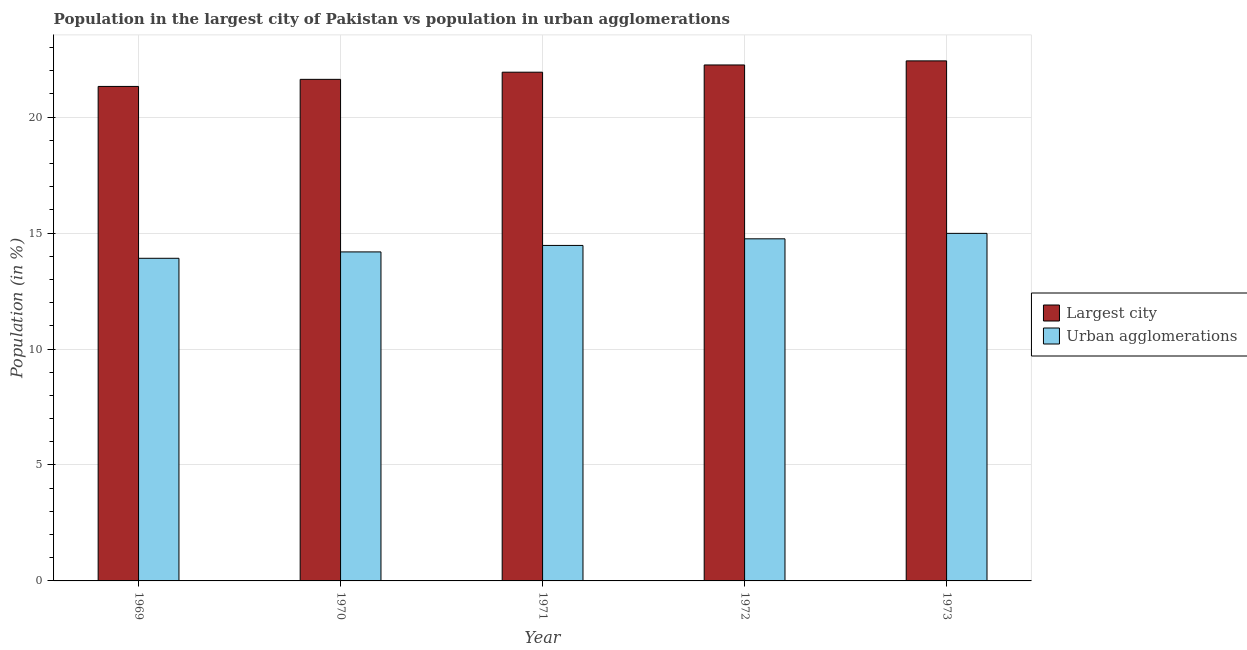How many bars are there on the 1st tick from the left?
Your response must be concise. 2. How many bars are there on the 2nd tick from the right?
Provide a short and direct response. 2. What is the label of the 5th group of bars from the left?
Offer a terse response. 1973. In how many cases, is the number of bars for a given year not equal to the number of legend labels?
Give a very brief answer. 0. What is the population in urban agglomerations in 1972?
Your answer should be compact. 14.75. Across all years, what is the maximum population in urban agglomerations?
Give a very brief answer. 14.99. Across all years, what is the minimum population in urban agglomerations?
Offer a terse response. 13.91. In which year was the population in urban agglomerations minimum?
Your answer should be compact. 1969. What is the total population in the largest city in the graph?
Ensure brevity in your answer.  109.58. What is the difference between the population in the largest city in 1969 and that in 1973?
Ensure brevity in your answer.  -1.1. What is the difference between the population in the largest city in 1969 and the population in urban agglomerations in 1970?
Keep it short and to the point. -0.31. What is the average population in the largest city per year?
Your response must be concise. 21.92. What is the ratio of the population in urban agglomerations in 1971 to that in 1972?
Your answer should be compact. 0.98. Is the difference between the population in the largest city in 1971 and 1972 greater than the difference between the population in urban agglomerations in 1971 and 1972?
Offer a terse response. No. What is the difference between the highest and the second highest population in the largest city?
Your response must be concise. 0.18. What is the difference between the highest and the lowest population in urban agglomerations?
Make the answer very short. 1.08. In how many years, is the population in urban agglomerations greater than the average population in urban agglomerations taken over all years?
Provide a short and direct response. 3. Is the sum of the population in urban agglomerations in 1972 and 1973 greater than the maximum population in the largest city across all years?
Provide a short and direct response. Yes. What does the 1st bar from the left in 1973 represents?
Provide a short and direct response. Largest city. What does the 2nd bar from the right in 1973 represents?
Your answer should be very brief. Largest city. What is the difference between two consecutive major ticks on the Y-axis?
Provide a short and direct response. 5. Are the values on the major ticks of Y-axis written in scientific E-notation?
Your answer should be very brief. No. How many legend labels are there?
Your response must be concise. 2. How are the legend labels stacked?
Your response must be concise. Vertical. What is the title of the graph?
Make the answer very short. Population in the largest city of Pakistan vs population in urban agglomerations. Does "Male entrants" appear as one of the legend labels in the graph?
Provide a succinct answer. No. What is the label or title of the X-axis?
Offer a terse response. Year. What is the Population (in %) of Largest city in 1969?
Offer a very short reply. 21.33. What is the Population (in %) in Urban agglomerations in 1969?
Provide a succinct answer. 13.91. What is the Population (in %) in Largest city in 1970?
Provide a succinct answer. 21.63. What is the Population (in %) of Urban agglomerations in 1970?
Give a very brief answer. 14.19. What is the Population (in %) in Largest city in 1971?
Keep it short and to the point. 21.94. What is the Population (in %) in Urban agglomerations in 1971?
Keep it short and to the point. 14.47. What is the Population (in %) in Largest city in 1972?
Keep it short and to the point. 22.25. What is the Population (in %) in Urban agglomerations in 1972?
Provide a short and direct response. 14.75. What is the Population (in %) in Largest city in 1973?
Your answer should be very brief. 22.43. What is the Population (in %) in Urban agglomerations in 1973?
Give a very brief answer. 14.99. Across all years, what is the maximum Population (in %) of Largest city?
Keep it short and to the point. 22.43. Across all years, what is the maximum Population (in %) in Urban agglomerations?
Your answer should be very brief. 14.99. Across all years, what is the minimum Population (in %) of Largest city?
Provide a short and direct response. 21.33. Across all years, what is the minimum Population (in %) of Urban agglomerations?
Give a very brief answer. 13.91. What is the total Population (in %) of Largest city in the graph?
Your response must be concise. 109.58. What is the total Population (in %) in Urban agglomerations in the graph?
Provide a short and direct response. 72.32. What is the difference between the Population (in %) in Largest city in 1969 and that in 1970?
Your answer should be very brief. -0.31. What is the difference between the Population (in %) of Urban agglomerations in 1969 and that in 1970?
Provide a short and direct response. -0.27. What is the difference between the Population (in %) of Largest city in 1969 and that in 1971?
Your answer should be very brief. -0.61. What is the difference between the Population (in %) in Urban agglomerations in 1969 and that in 1971?
Keep it short and to the point. -0.55. What is the difference between the Population (in %) in Largest city in 1969 and that in 1972?
Provide a succinct answer. -0.93. What is the difference between the Population (in %) in Urban agglomerations in 1969 and that in 1972?
Provide a succinct answer. -0.84. What is the difference between the Population (in %) of Largest city in 1969 and that in 1973?
Offer a terse response. -1.1. What is the difference between the Population (in %) of Urban agglomerations in 1969 and that in 1973?
Offer a terse response. -1.07. What is the difference between the Population (in %) of Largest city in 1970 and that in 1971?
Provide a succinct answer. -0.31. What is the difference between the Population (in %) in Urban agglomerations in 1970 and that in 1971?
Ensure brevity in your answer.  -0.28. What is the difference between the Population (in %) in Largest city in 1970 and that in 1972?
Offer a very short reply. -0.62. What is the difference between the Population (in %) in Urban agglomerations in 1970 and that in 1972?
Your response must be concise. -0.57. What is the difference between the Population (in %) in Largest city in 1970 and that in 1973?
Offer a very short reply. -0.8. What is the difference between the Population (in %) in Urban agglomerations in 1970 and that in 1973?
Your answer should be very brief. -0.8. What is the difference between the Population (in %) of Largest city in 1971 and that in 1972?
Make the answer very short. -0.31. What is the difference between the Population (in %) in Urban agglomerations in 1971 and that in 1972?
Your answer should be compact. -0.29. What is the difference between the Population (in %) of Largest city in 1971 and that in 1973?
Keep it short and to the point. -0.49. What is the difference between the Population (in %) of Urban agglomerations in 1971 and that in 1973?
Provide a short and direct response. -0.52. What is the difference between the Population (in %) of Largest city in 1972 and that in 1973?
Offer a very short reply. -0.18. What is the difference between the Population (in %) in Urban agglomerations in 1972 and that in 1973?
Offer a very short reply. -0.23. What is the difference between the Population (in %) of Largest city in 1969 and the Population (in %) of Urban agglomerations in 1970?
Your response must be concise. 7.14. What is the difference between the Population (in %) in Largest city in 1969 and the Population (in %) in Urban agglomerations in 1971?
Your answer should be compact. 6.86. What is the difference between the Population (in %) in Largest city in 1969 and the Population (in %) in Urban agglomerations in 1972?
Your answer should be very brief. 6.57. What is the difference between the Population (in %) in Largest city in 1969 and the Population (in %) in Urban agglomerations in 1973?
Make the answer very short. 6.34. What is the difference between the Population (in %) in Largest city in 1970 and the Population (in %) in Urban agglomerations in 1971?
Offer a terse response. 7.16. What is the difference between the Population (in %) of Largest city in 1970 and the Population (in %) of Urban agglomerations in 1972?
Ensure brevity in your answer.  6.88. What is the difference between the Population (in %) of Largest city in 1970 and the Population (in %) of Urban agglomerations in 1973?
Provide a succinct answer. 6.64. What is the difference between the Population (in %) in Largest city in 1971 and the Population (in %) in Urban agglomerations in 1972?
Your answer should be compact. 7.19. What is the difference between the Population (in %) in Largest city in 1971 and the Population (in %) in Urban agglomerations in 1973?
Provide a succinct answer. 6.95. What is the difference between the Population (in %) of Largest city in 1972 and the Population (in %) of Urban agglomerations in 1973?
Provide a succinct answer. 7.26. What is the average Population (in %) of Largest city per year?
Make the answer very short. 21.92. What is the average Population (in %) in Urban agglomerations per year?
Offer a terse response. 14.46. In the year 1969, what is the difference between the Population (in %) in Largest city and Population (in %) in Urban agglomerations?
Give a very brief answer. 7.41. In the year 1970, what is the difference between the Population (in %) in Largest city and Population (in %) in Urban agglomerations?
Offer a terse response. 7.44. In the year 1971, what is the difference between the Population (in %) of Largest city and Population (in %) of Urban agglomerations?
Make the answer very short. 7.47. In the year 1972, what is the difference between the Population (in %) of Largest city and Population (in %) of Urban agglomerations?
Make the answer very short. 7.5. In the year 1973, what is the difference between the Population (in %) in Largest city and Population (in %) in Urban agglomerations?
Make the answer very short. 7.44. What is the ratio of the Population (in %) of Largest city in 1969 to that in 1970?
Offer a terse response. 0.99. What is the ratio of the Population (in %) of Urban agglomerations in 1969 to that in 1970?
Make the answer very short. 0.98. What is the ratio of the Population (in %) in Urban agglomerations in 1969 to that in 1971?
Provide a succinct answer. 0.96. What is the ratio of the Population (in %) of Largest city in 1969 to that in 1972?
Ensure brevity in your answer.  0.96. What is the ratio of the Population (in %) of Urban agglomerations in 1969 to that in 1972?
Ensure brevity in your answer.  0.94. What is the ratio of the Population (in %) of Largest city in 1969 to that in 1973?
Your answer should be compact. 0.95. What is the ratio of the Population (in %) in Urban agglomerations in 1969 to that in 1973?
Provide a succinct answer. 0.93. What is the ratio of the Population (in %) of Largest city in 1970 to that in 1971?
Give a very brief answer. 0.99. What is the ratio of the Population (in %) of Urban agglomerations in 1970 to that in 1971?
Your answer should be compact. 0.98. What is the ratio of the Population (in %) in Largest city in 1970 to that in 1972?
Your answer should be compact. 0.97. What is the ratio of the Population (in %) in Urban agglomerations in 1970 to that in 1972?
Your answer should be very brief. 0.96. What is the ratio of the Population (in %) in Largest city in 1970 to that in 1973?
Your answer should be very brief. 0.96. What is the ratio of the Population (in %) in Urban agglomerations in 1970 to that in 1973?
Ensure brevity in your answer.  0.95. What is the ratio of the Population (in %) of Largest city in 1971 to that in 1972?
Offer a very short reply. 0.99. What is the ratio of the Population (in %) of Urban agglomerations in 1971 to that in 1972?
Your response must be concise. 0.98. What is the ratio of the Population (in %) of Largest city in 1971 to that in 1973?
Keep it short and to the point. 0.98. What is the ratio of the Population (in %) in Urban agglomerations in 1971 to that in 1973?
Your answer should be compact. 0.97. What is the ratio of the Population (in %) of Largest city in 1972 to that in 1973?
Your answer should be very brief. 0.99. What is the ratio of the Population (in %) in Urban agglomerations in 1972 to that in 1973?
Your response must be concise. 0.98. What is the difference between the highest and the second highest Population (in %) in Largest city?
Keep it short and to the point. 0.18. What is the difference between the highest and the second highest Population (in %) of Urban agglomerations?
Your answer should be very brief. 0.23. What is the difference between the highest and the lowest Population (in %) of Largest city?
Your answer should be compact. 1.1. What is the difference between the highest and the lowest Population (in %) of Urban agglomerations?
Provide a short and direct response. 1.07. 